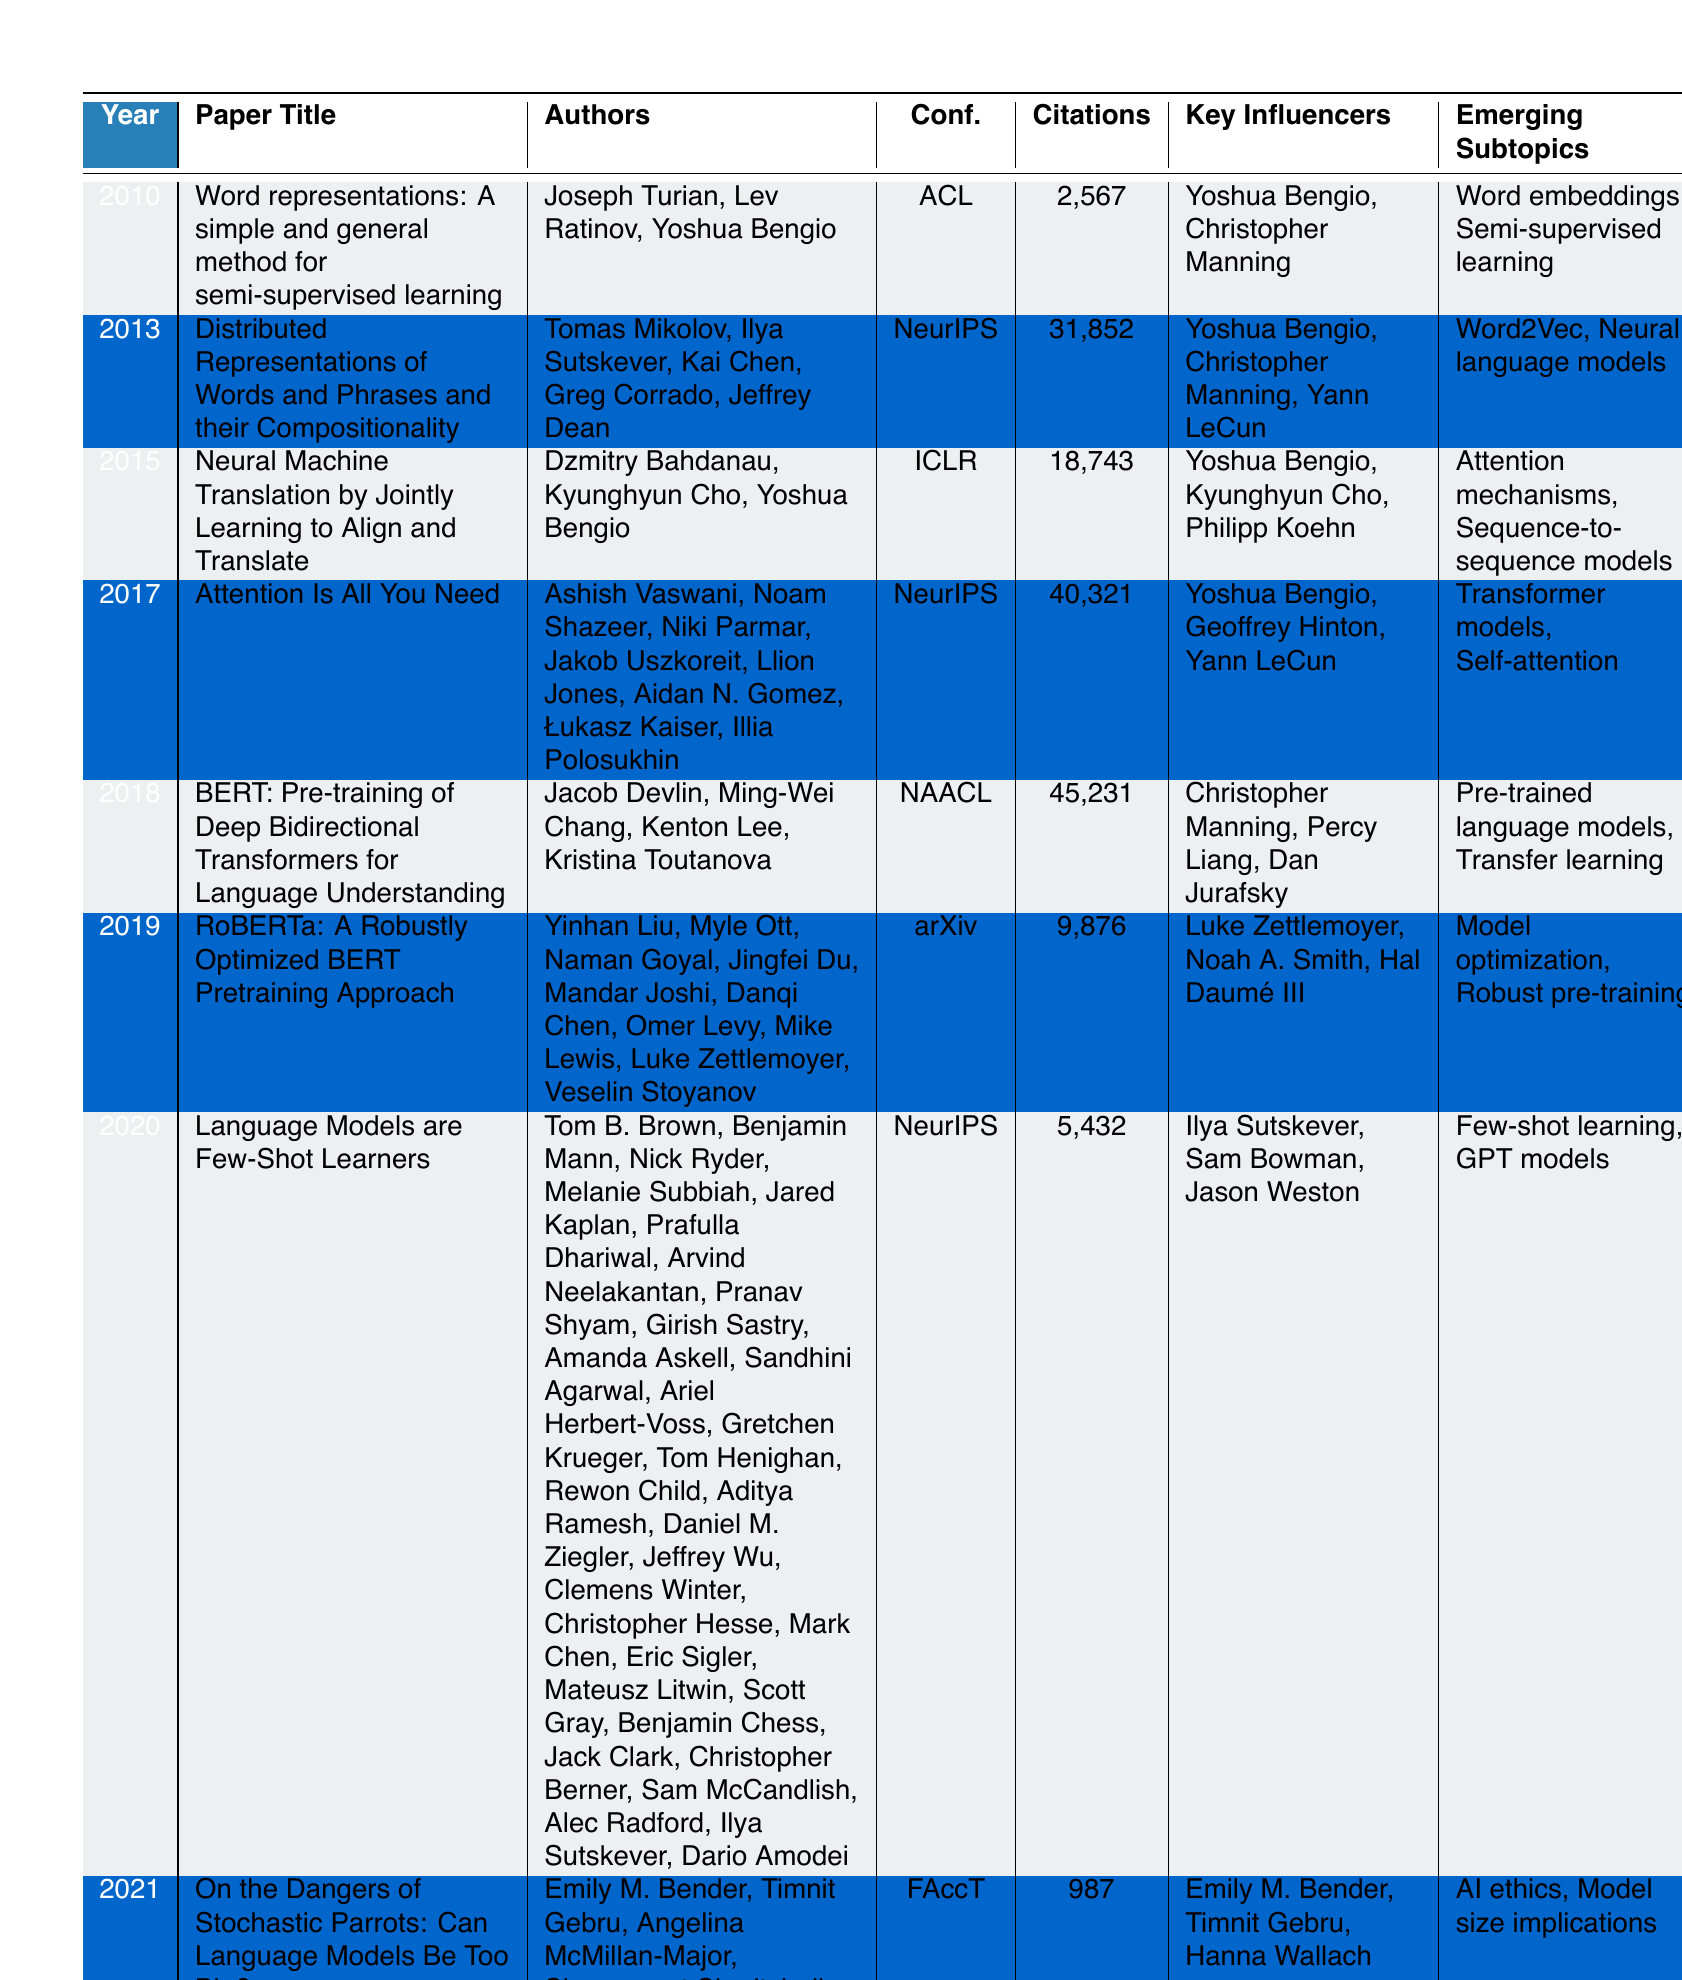What is the highest citation count in the table? The highest citation count can be found by examining the Citation Count column. Upon reviewing the values, 45,231 from the paper titled "BERT: Pre-training of Deep Bidirectional Transformers for Language Understanding" is the largest value in the column.
Answer: 45,231 Which paper was published in 2019? The 2019 entry in the Year column corresponds to the paper titled "RoBERTa: A Robustly Optimized BERT Pretraining Approach." This can be directly identified by locating the year and reading the associated title.
Answer: RoBERTa: A Robustly Optimized BERT Pretraining Approach How many papers have a citation count greater than 20,000? First, we filter the Citation Count column for values greater than 20,000. The papers with citation counts of 31,852, 40,321, and 45,231 fit this criterion. Thus, we count these entries, which total to three.
Answer: 3 Identify the key influencers for the paper 'Attention Is All You Need.' By locating the paper titled "Attention Is All You Need" in the table under 2017, we see that the Key Influencers column lists "Yoshua Bengio, Geoffrey Hinton, Yann LeCun" associated with this paper.
Answer: Yoshua Bengio, Geoffrey Hinton, Yann LeCun What is the average citation count of all papers listed in the table? To find the average, we sum all citation counts: 2567 + 31852 + 18743 + 40321 + 45231 + 9876 + 5432 + 987 = 101,059. There are 8 papers, so we divide the sum by 8 to obtain the average: 101,059 / 8 = 12,632.375, rounded to 12,632.
Answer: 12,632 Did any paper from 2021 receive more citations than the 2019 paper? The paper from 2019 received 9,876 citations. The 2021 paper "On the Dangers of Stochastic Parrots: Can Language Models Be Too Big?" has a citation count of 987. Since 987 is less than 9,876, the answer is no.
Answer: No Which emerging subtopic is associated with the highest cited paper? The paper "BERT: Pre-training of Deep Bidirectional Transformers for Language Understanding" which has the highest citation count of 45,231 is associated with the emerging subtopics "Pre-trained language models, Transfer learning."
Answer: Pre-trained language models, Transfer learning How many authors contributed to the paper "Language Models are Few-Shot Learners"? By locating the row for "Language Models are Few-Shot Learners," we can count the authors listed: there are 21 authors named in that entry.
Answer: 21 Which conference had the most papers listed in the table? We review the Conference column and find that "NeurIPS" is listed three times (2013, 2017, and 2020). Other conferences appear less frequently. Therefore, "NeurIPS" hosts the most papers.
Answer: NeurIPS Which year saw a significant leap in citation counts compared to previous years? The citation counts in the years leading up to 2018 show an increase, but notably, the count jumped from 18,743 in 2015 to 40,321 in 2017, indicating a significant leap of over 21,000 citations in just two years.
Answer: 2017 What emerging subtopic is common between papers from 2015 and 2017? We check the emerging subtopics for papers from 2015 and 2017. The paper from 2015 mentions "Attention mechanisms, Sequence-to-sequence models," and the paper from 2017 lists "Transformer models, Self-attention." Both papers involve attention mechanisms in some form, indicating a shared interest in this subtopic.
Answer: Attention mechanisms 